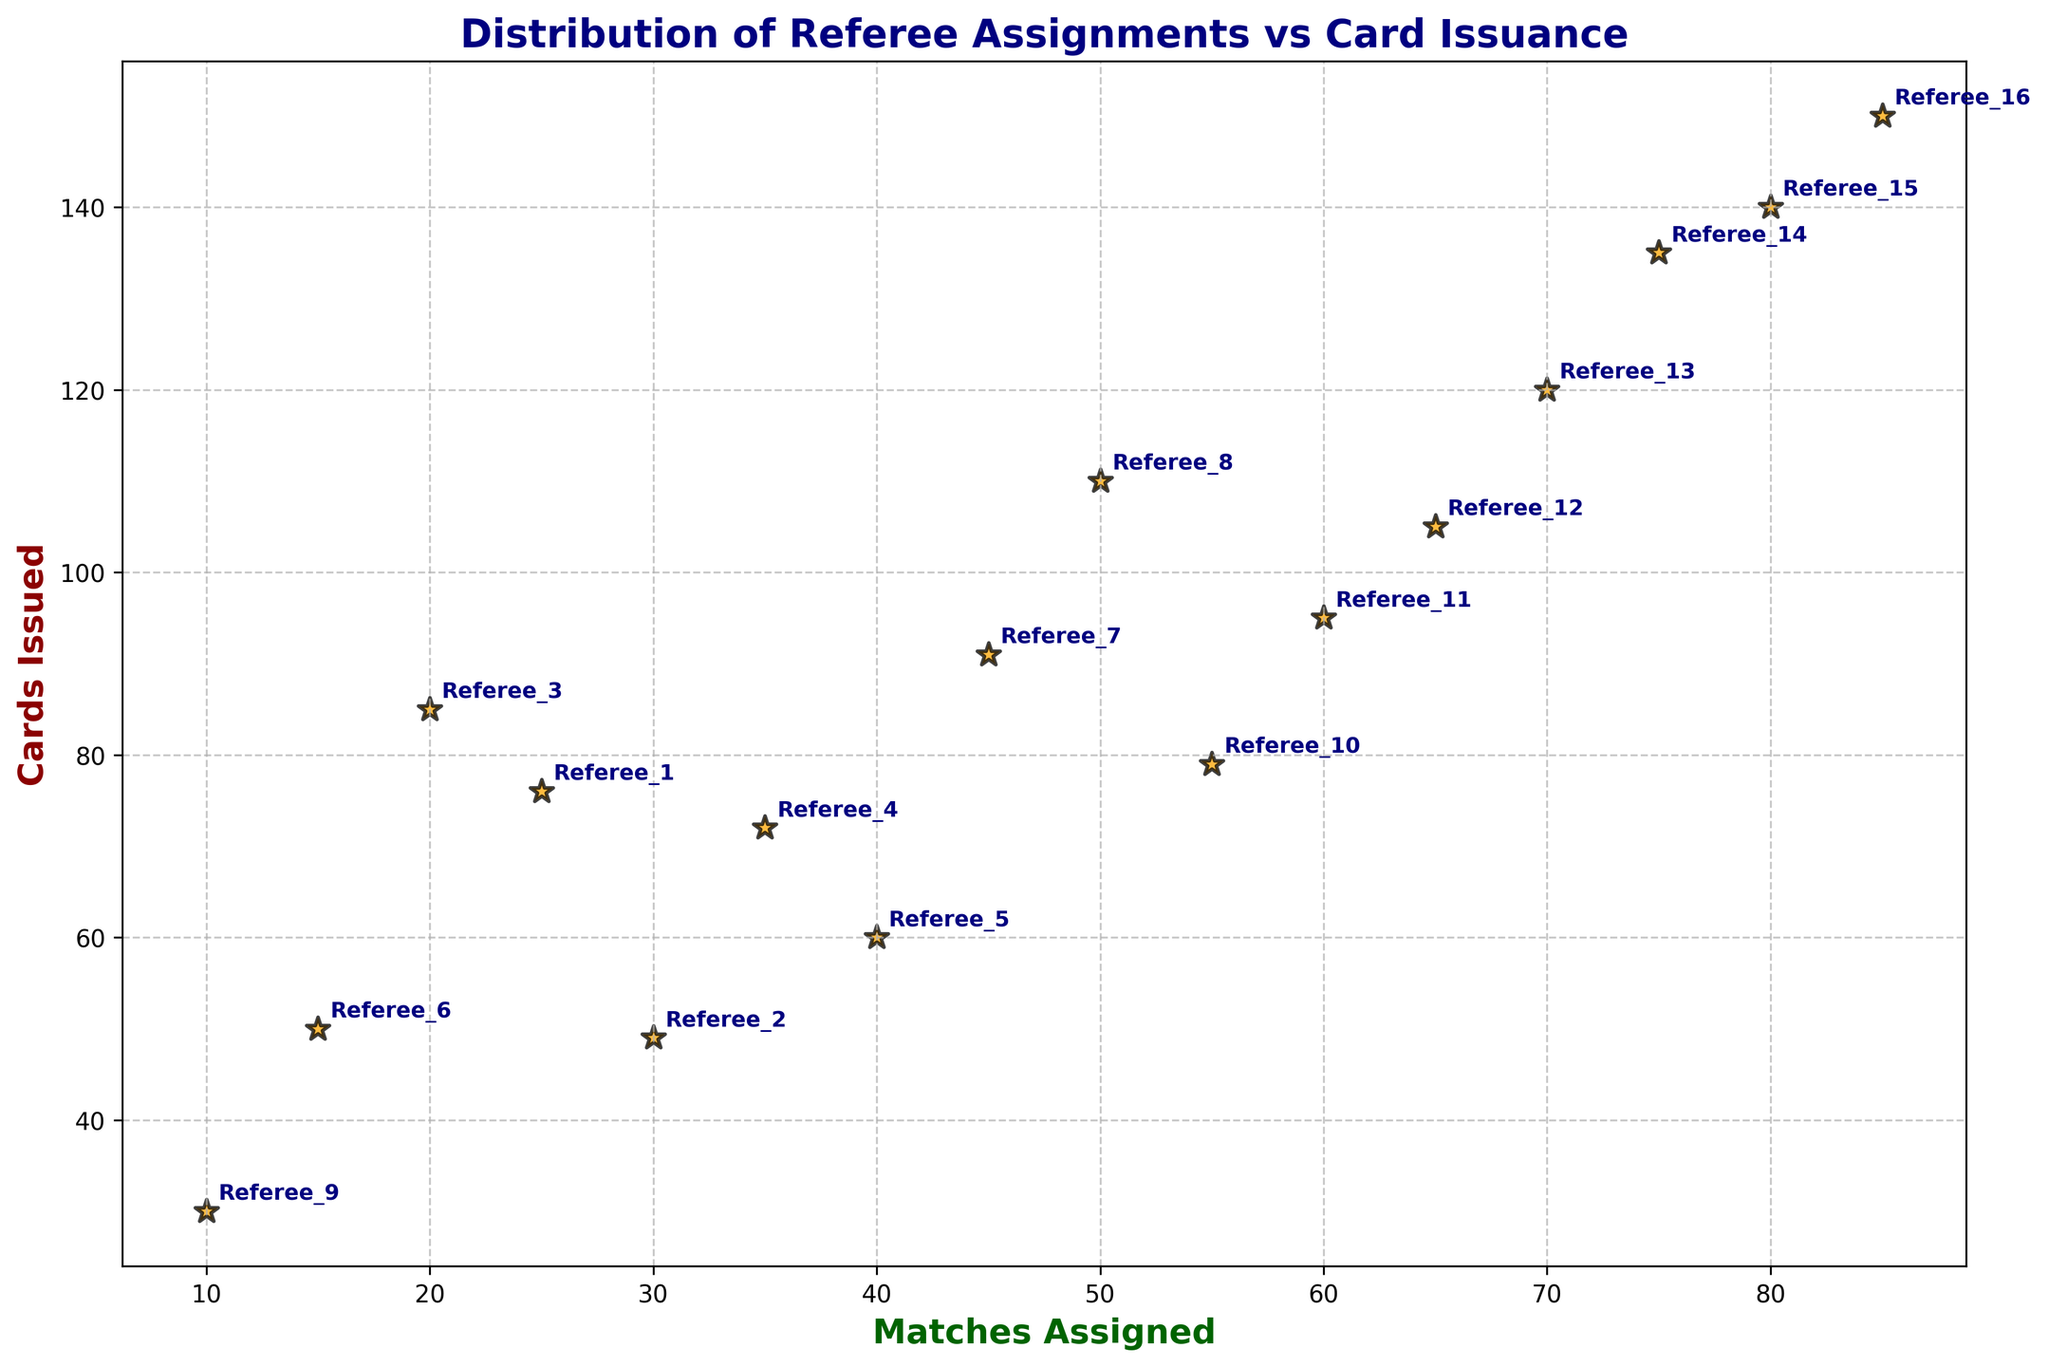Which referee was assigned the maximum number of matches? By examining the plot, we note which referee has the highest x-coordinate value (matches assigned). Referee_16, with 85 matches, is the maximum.
Answer: Referee_16 Who issued the most cards? By checking the plot for the referee with the highest y-coordinate value (cards issued), we see that Referee_16, with 150 cards, issued the most.
Answer: Referee_16 Which two referees have been assigned an equal number of matches but have a different number of cards issued? We look for referees who share the same x-value but differ in y-value. Referee_1 and Referee_3 both have been assigned 20 matches, but differ in cards issued.
Answer: Referee_1 and Referee_3 What is the correlation between matches assigned and cards issued? By visually inspecting the scatter plot, we can see a general upward trend; as matches assigned increase, cards issued tend to increase as well. This indicates a positive correlation.
Answer: Positive correlation Between Referee_5 and Referee_11, who issued more cards? Comparing their y-values in the plot, Referee_11 issued 95 cards, more than Referee_5 who issued 60 cards.
Answer: Referee_11 Which referee issued the fewest cards? The referee with the lowest y-coordinate value (cards issued) is Referee_9 with 30 cards.
Answer: Referee_9 Is there any referee who issued exactly 100 cards? By checking the y-values, we do not see any referee whose cards issued equals 100.
Answer: No Calculate the difference in the number of cards issued between the referee assigned the most matches and the referee assigned the fewest matches. Referee_16 has 150 cards issued and Referee_9 has 30 cards issued. The difference is 150 - 30 = 120.
Answer: 120 Which referee, assigned to at least 25 matches, issued the fewest number of cards? Among referees assigned at least 25 matches, the fewest cards 49 are issued by Referee_2.
Answer: Referee_2 Do referees assigned more matches generally issue more cards? We observe the trend in the scatter plot and see that as matches assigned increase on the x-axis, the cards issued on the y-axis also generally increase, suggesting that referees assigned more matches tend to issue more cards.
Answer: Yes 